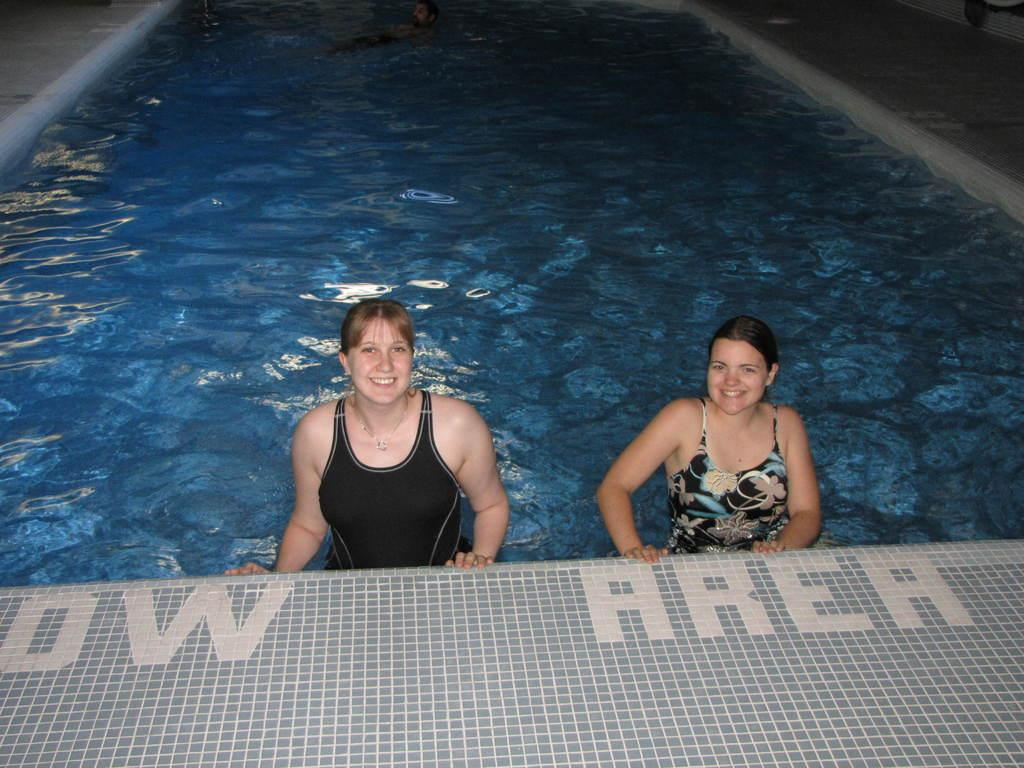How many people are in the swimming pool in the image? There are two persons in the swimming pool. What can be seen on the floor in front of the swimming pool? There is text visible on the floor in front of the swimming pool. What is the reaction of the person in the image when they see the angle of the mouth? There is no person's reaction or mouth visible in the image; it only shows two persons in the swimming pool and text on the floor. 